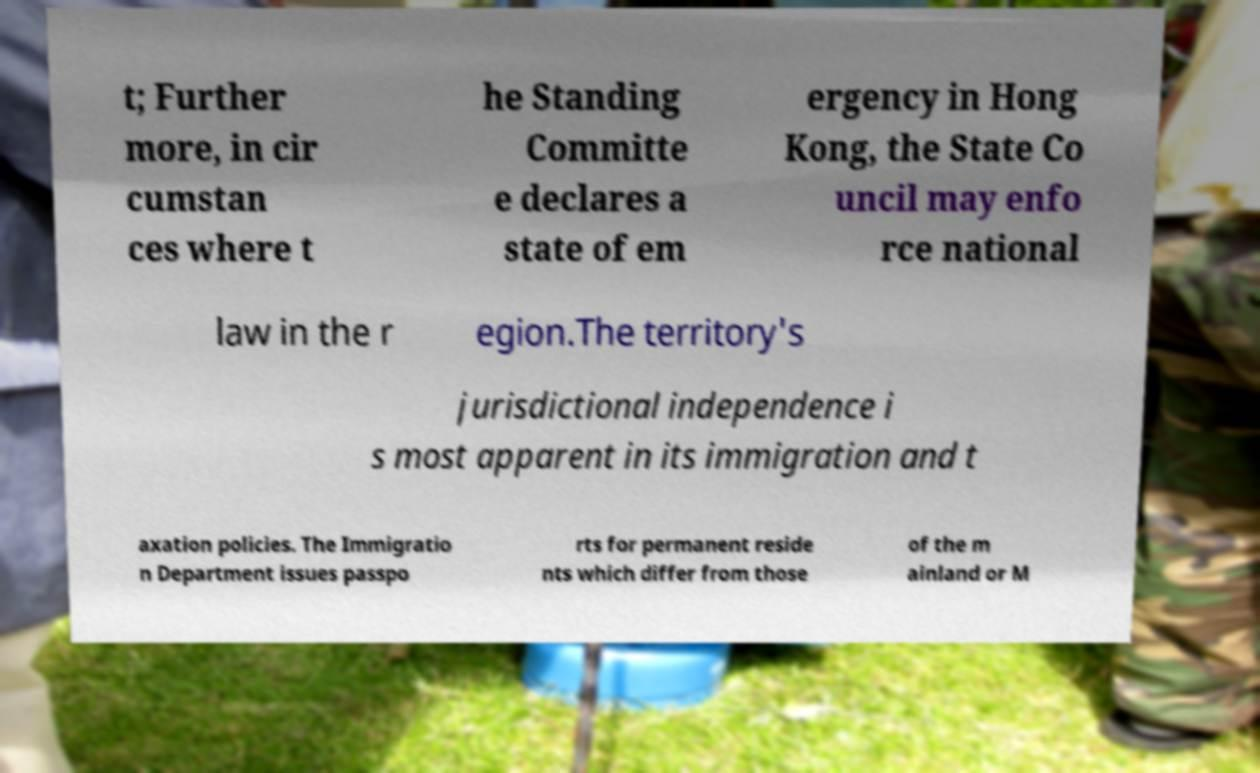I need the written content from this picture converted into text. Can you do that? t; Further more, in cir cumstan ces where t he Standing Committe e declares a state of em ergency in Hong Kong, the State Co uncil may enfo rce national law in the r egion.The territory's jurisdictional independence i s most apparent in its immigration and t axation policies. The Immigratio n Department issues passpo rts for permanent reside nts which differ from those of the m ainland or M 